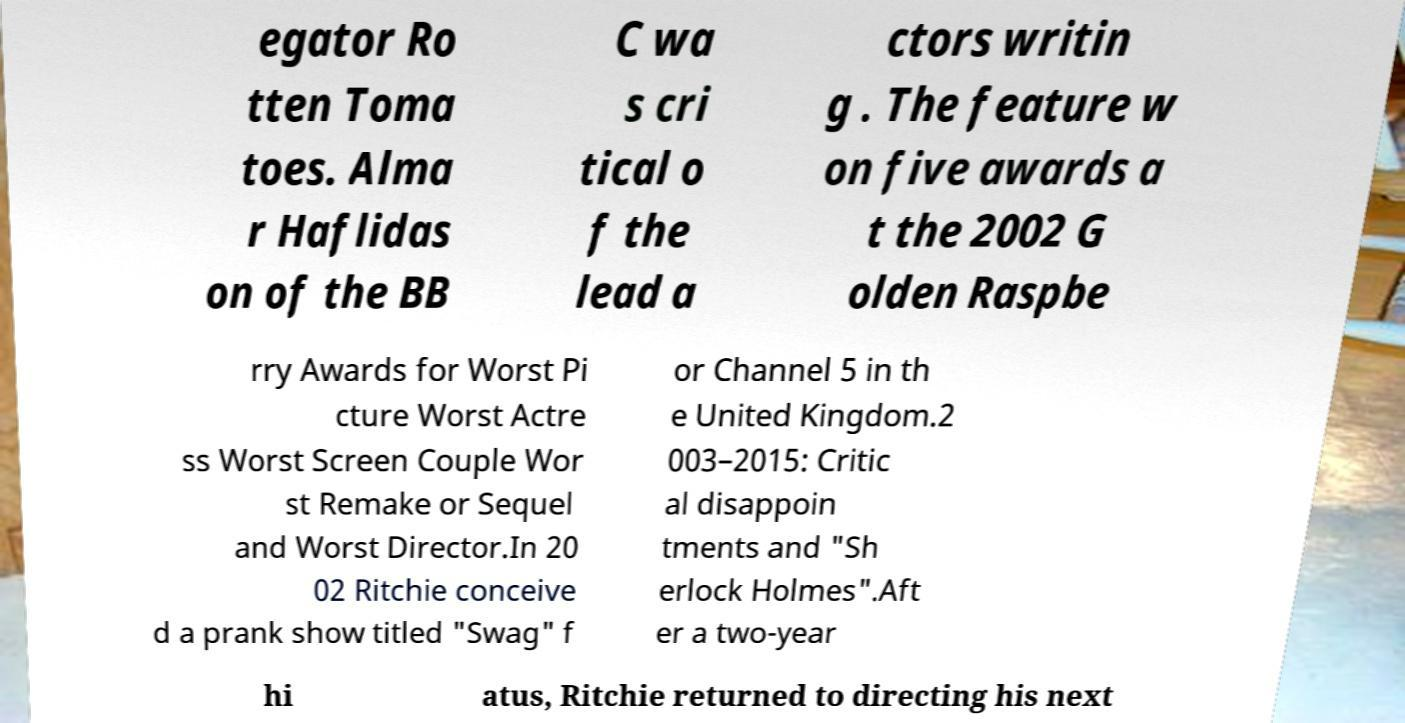What messages or text are displayed in this image? I need them in a readable, typed format. egator Ro tten Toma toes. Alma r Haflidas on of the BB C wa s cri tical o f the lead a ctors writin g . The feature w on five awards a t the 2002 G olden Raspbe rry Awards for Worst Pi cture Worst Actre ss Worst Screen Couple Wor st Remake or Sequel and Worst Director.In 20 02 Ritchie conceive d a prank show titled "Swag" f or Channel 5 in th e United Kingdom.2 003–2015: Critic al disappoin tments and "Sh erlock Holmes".Aft er a two-year hi atus, Ritchie returned to directing his next 